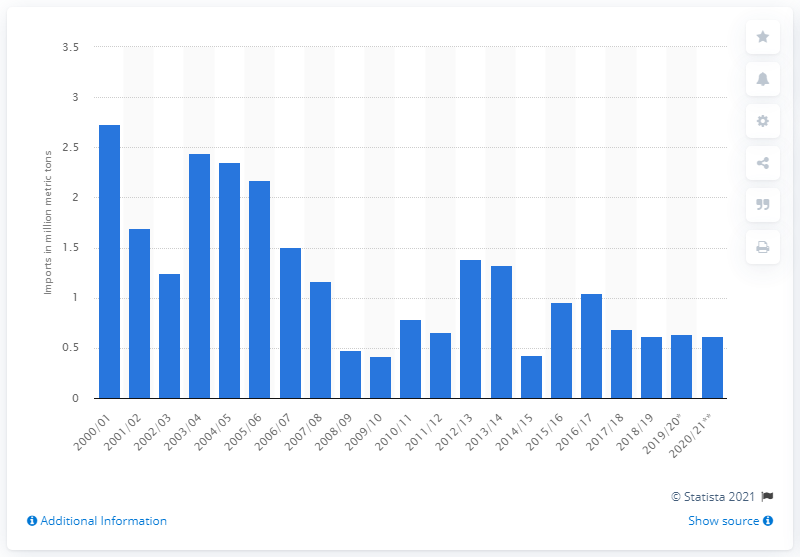Draw attention to some important aspects in this diagram. According to the forecast, Russia's cereal imports for the years 2020/2021 were expected to be 0.62 million metric tons. 